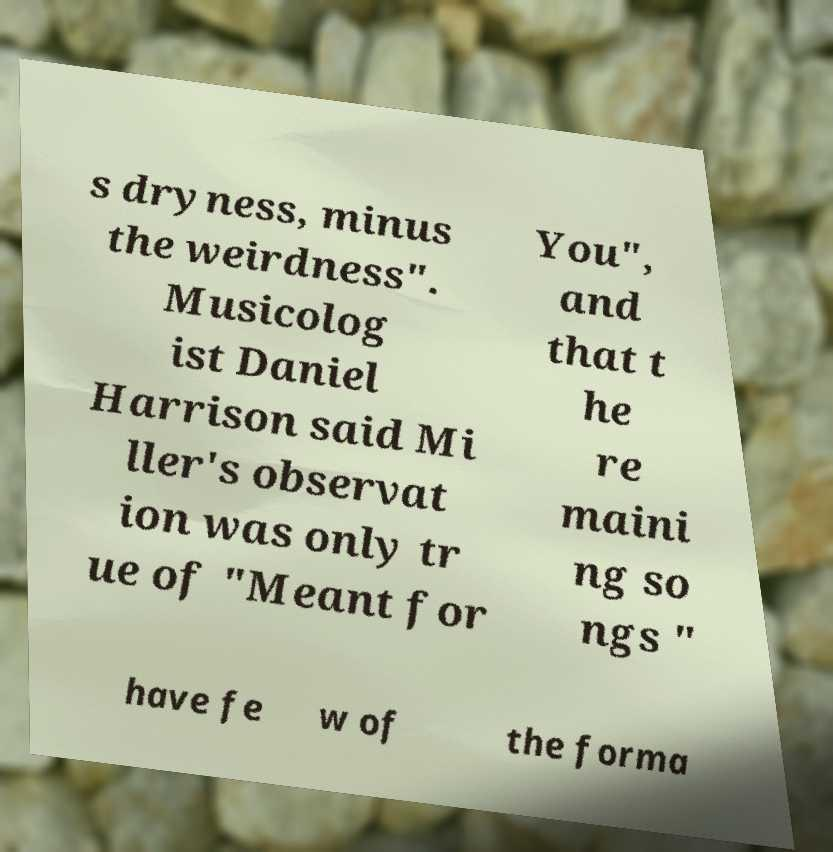Could you extract and type out the text from this image? s dryness, minus the weirdness". Musicolog ist Daniel Harrison said Mi ller's observat ion was only tr ue of "Meant for You", and that t he re maini ng so ngs " have fe w of the forma 